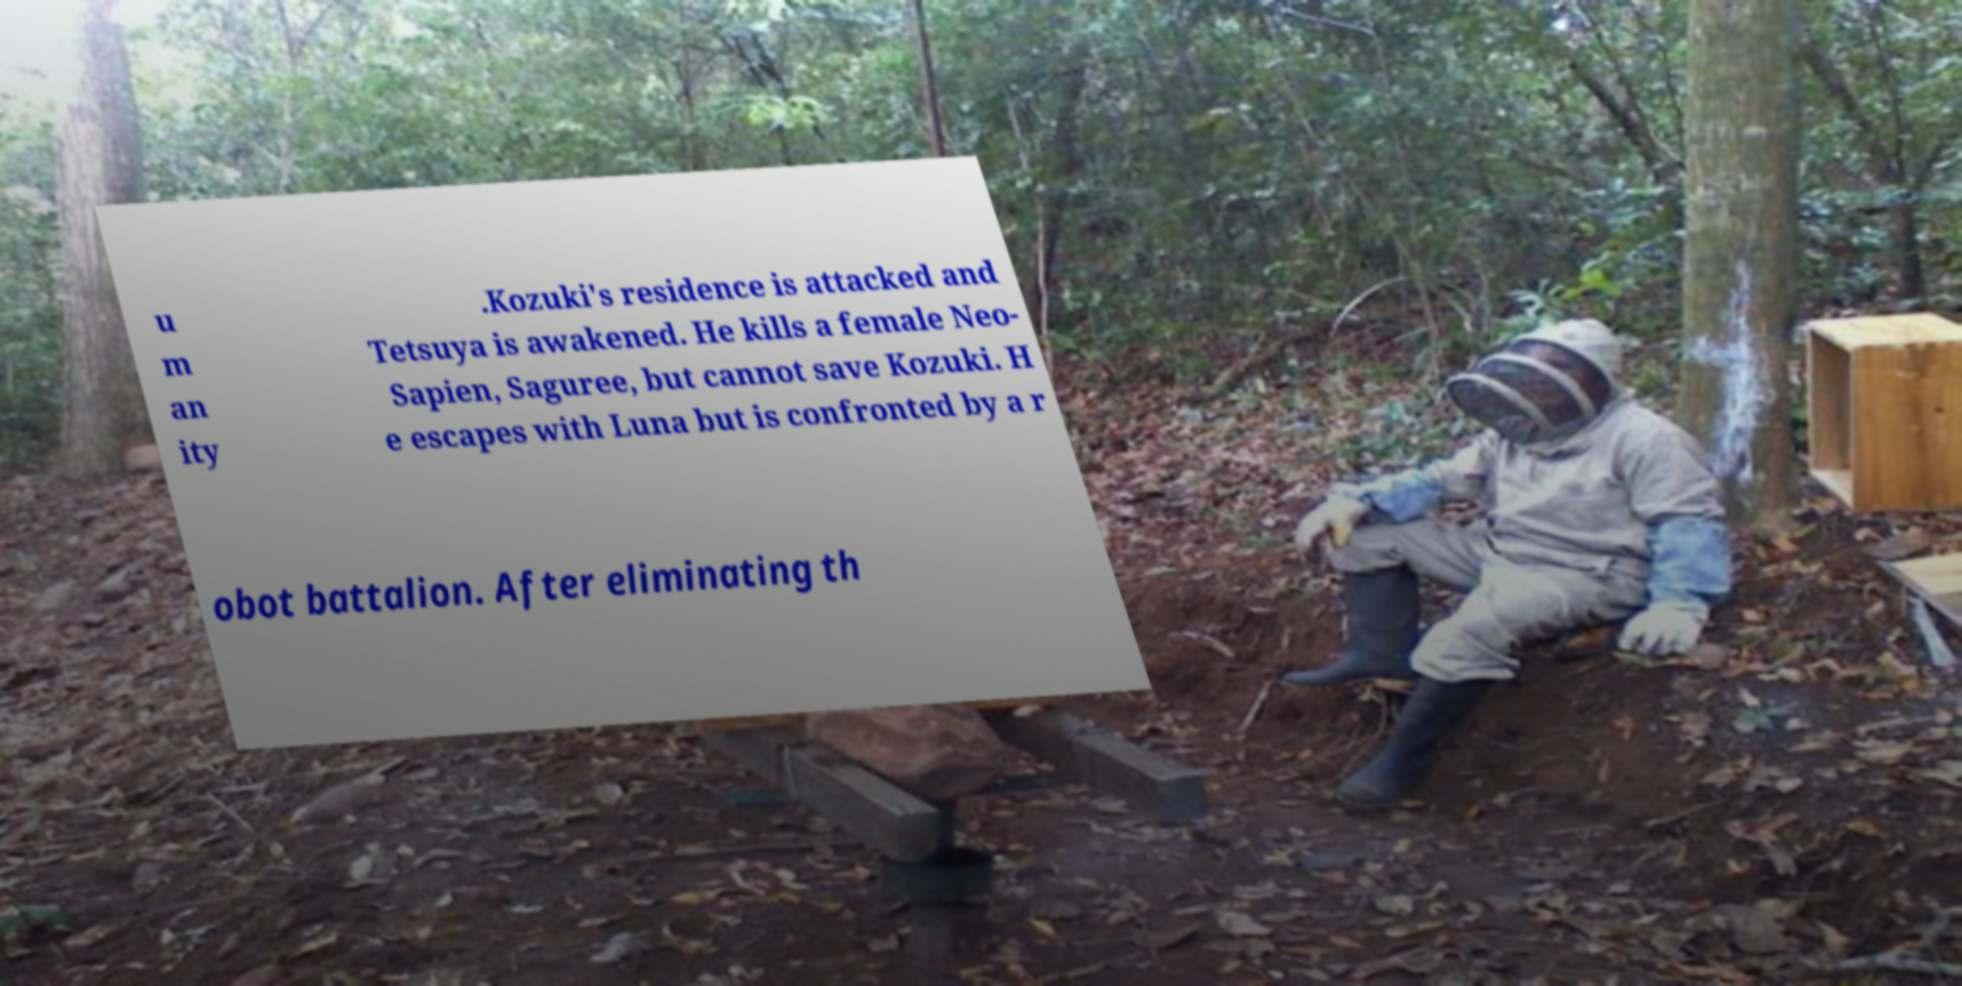Can you accurately transcribe the text from the provided image for me? u m an ity .Kozuki's residence is attacked and Tetsuya is awakened. He kills a female Neo- Sapien, Saguree, but cannot save Kozuki. H e escapes with Luna but is confronted by a r obot battalion. After eliminating th 